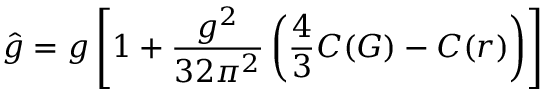<formula> <loc_0><loc_0><loc_500><loc_500>\hat { g } = g \left [ 1 + \frac { g ^ { 2 } } { 3 2 \pi ^ { 2 } } \left ( \frac { 4 } { 3 } C ( G ) - C ( r ) \right ) \right ]</formula> 